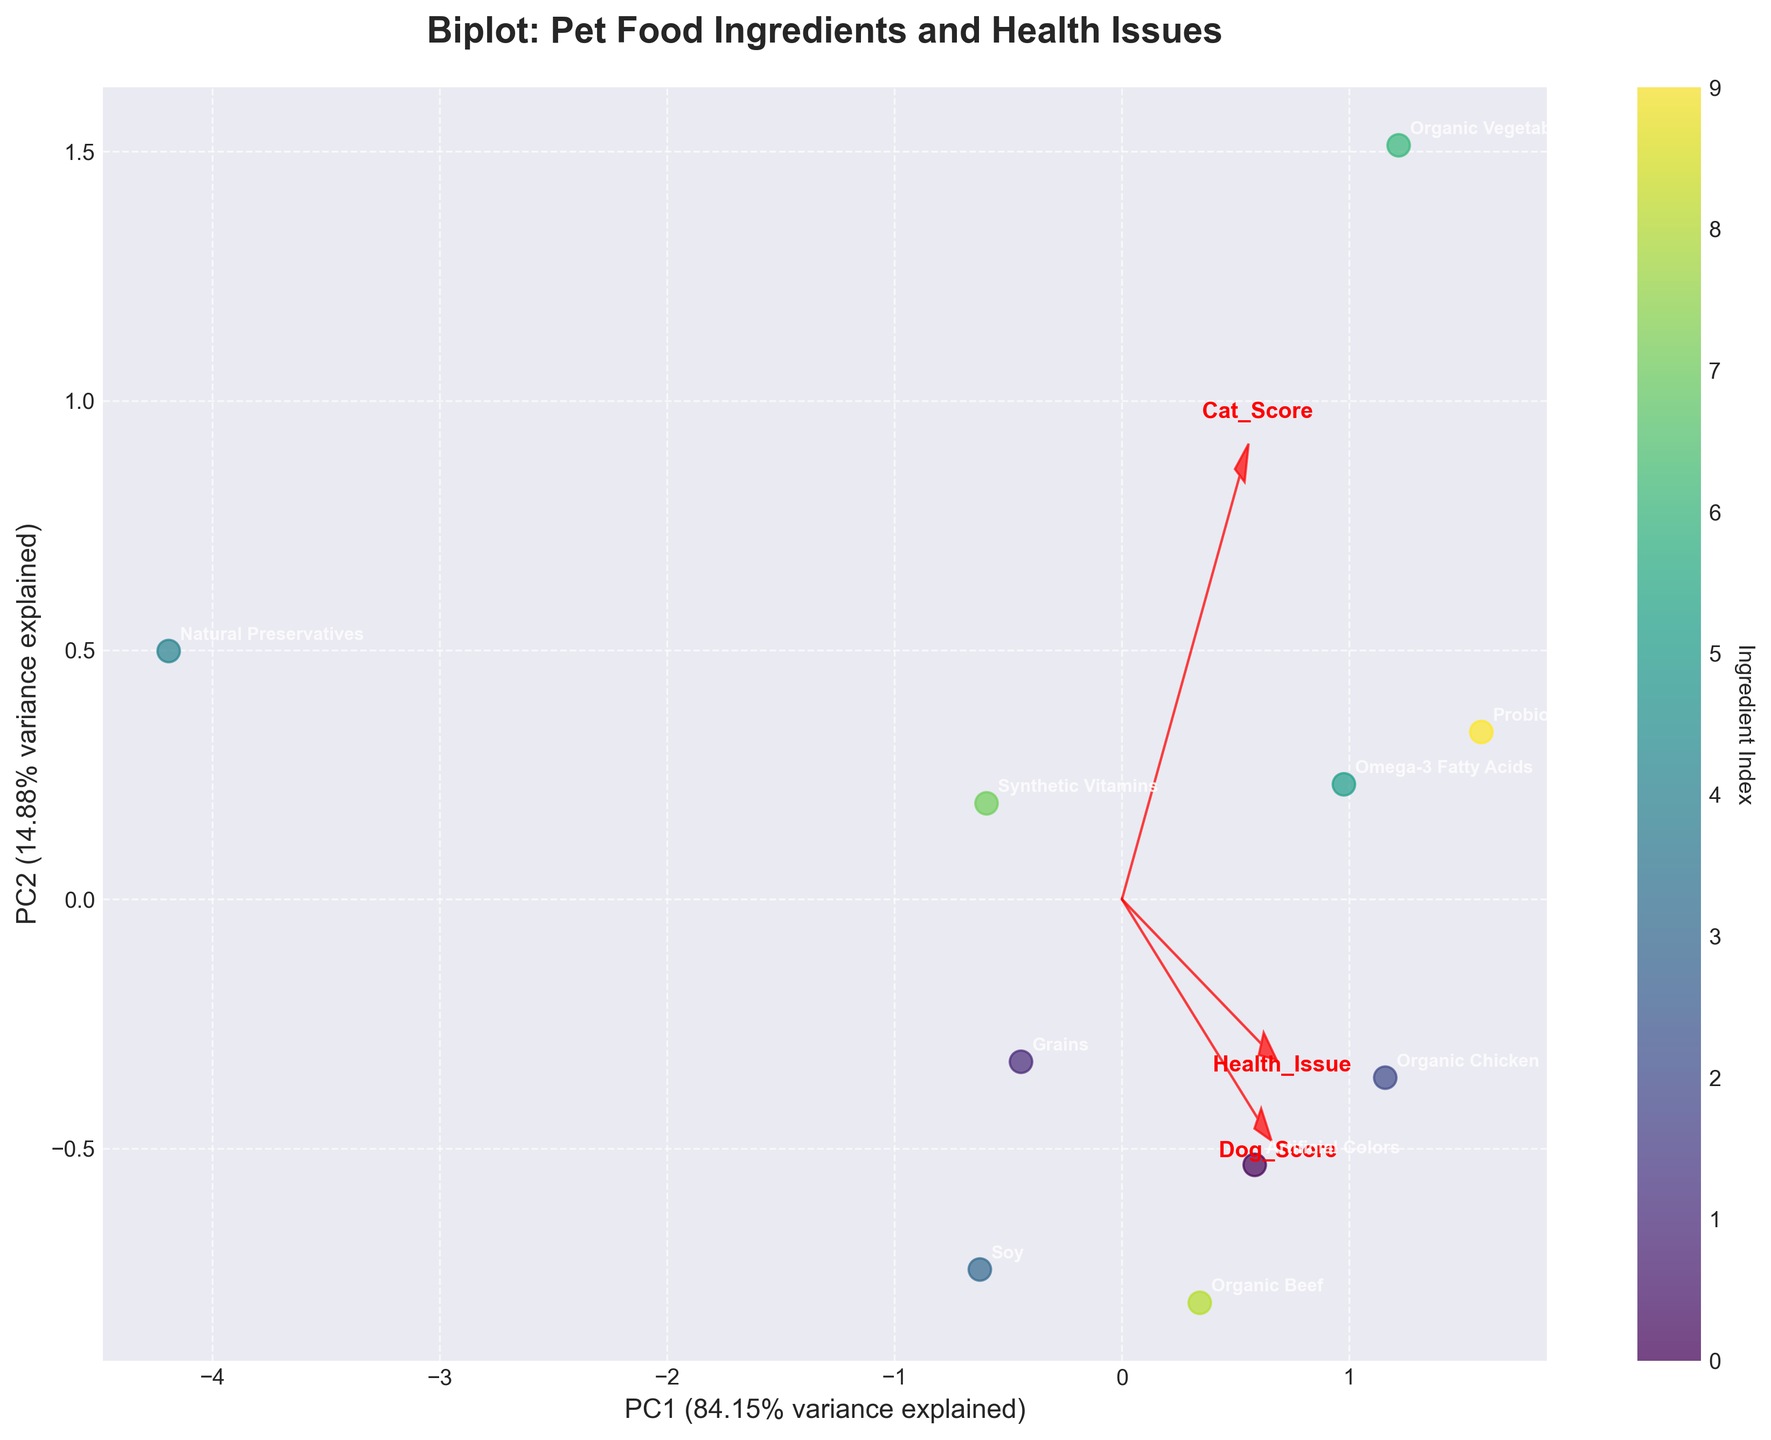How many types of pet food ingredients are shown in the biplot? Count the number of distinct names labeled on the plot.
Answer: 10 Which ingredient is associated with "Improved Coat" in dogs? Identify the text label near the data point that aligns with the health issue "Improved Coat."
Answer: Organic Chicken Which health issue is most strongly correlated with Omega-3 Fatty Acids? Look for the text label "Omega-3 Fatty Acids" and find the associated health issue.
Answer: Joint Health Do Artificial Colors and Natural Preservatives have positive or negative health impacts on pets? Observe the direction of the arrows: if they extend into the upper right quadrant, the impact is positive; if they point downward or to the left, the impact is negative.
Answer: Artificial Colors: Positive, Natural Preservatives: Negative What are the first two principal components in the biplot? The plot's X and Y axes indicate the first two principal components, labeled accordingly.
Answer: PC1 and PC2 Which ingredient is represented closest to the origin? Find the ingredient label that appears nearest to the (0,0) point on the plot.
Answer: Synthetic Vitamins Which ingredient has the highest score for birds? Look for the label closest to the data point furthest along the axis associated with bird score.
Answer: Organic Vegetables Are any ingredients' arrows pointing directly in opposite directions? What does this imply? Check if any arrows point in diametrically opposite directions and assess their meanings.
Answer: No, none are precisely opposite; similar directions indicate similar impacts, opposites suggest inverse impacts Which ingredient has a stronger impact on dogs compared to cats according to the biplot vectors? Compare the vector lengths pointing towards Dog_Score vs. Cat_Score; longer vectors indicate a stronger impact.
Answer: Omega-3 Fatty Acids Is there evidence that organic ingredients generally have healthier impacts on pets according to the biplot? Look at the directions and magnitudes of arrows for organic ingredients and associated health impacts to conclude if they point towards positive outcomes.
Answer: Yes 